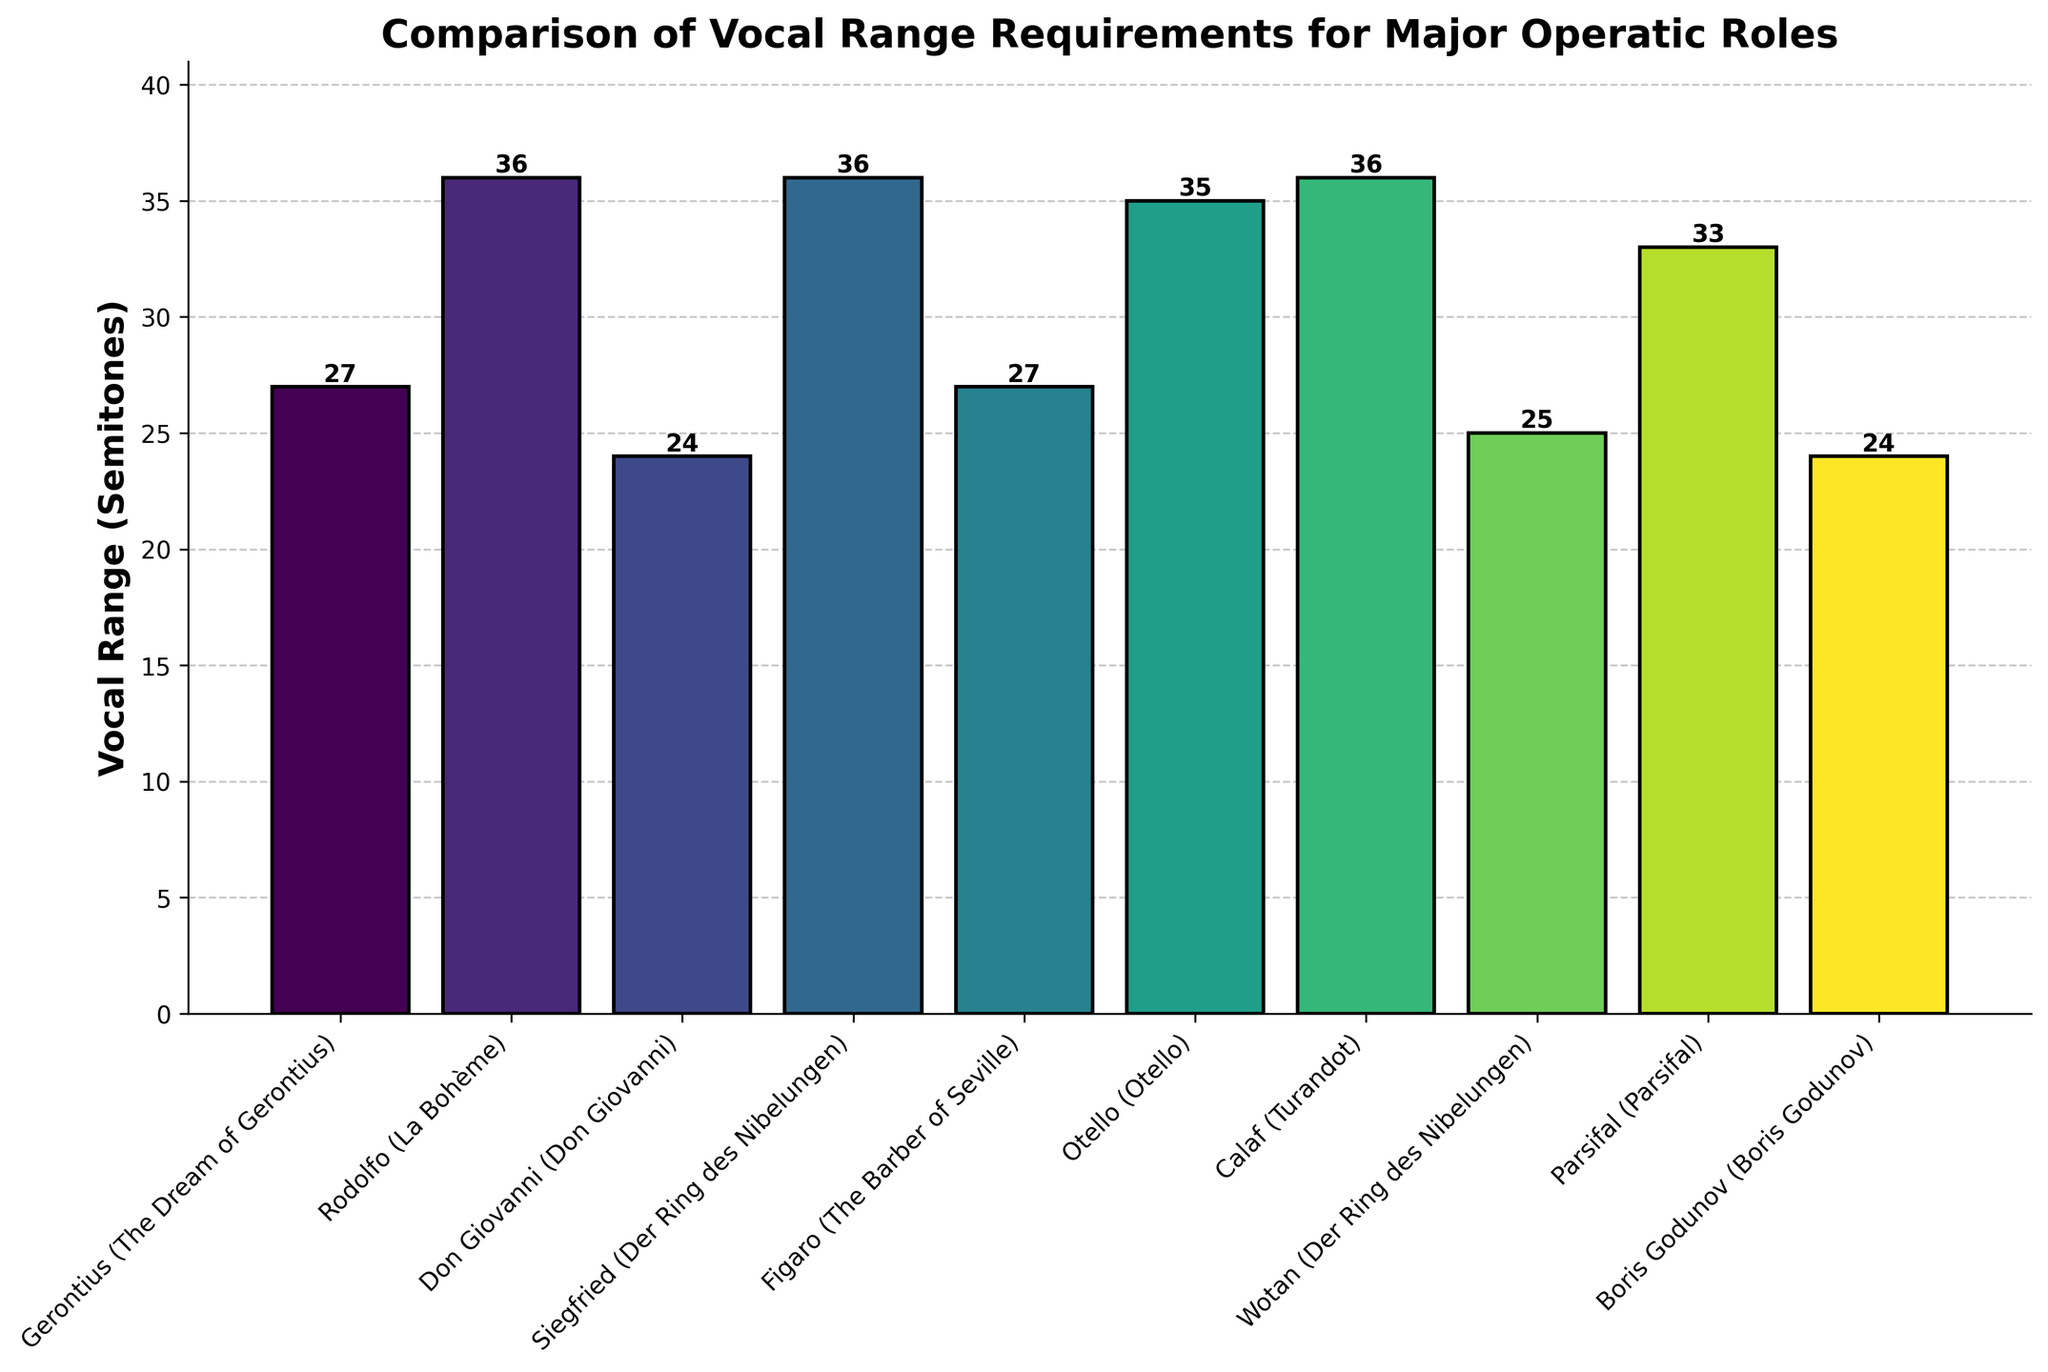What is the vocal range of Rodolfo in "La Bohème"? Look at the bar corresponding to Rodolfo in "La Bohème" and find the height, which represents the vocal range (semitones).
Answer: 36 Which operatic role has the widest vocal range, and what is that range? Identify the tallest bar in the chart and check the label and value attached to it.
Answer: Rodolfo and Siegfried with 36 semitones Which role has a narrower vocal range, Don Giovanni or Gerontius? Compare the heights of the bars for Don Giovanni and Gerontius. Don Giovanni's bar is shorter.
Answer: Don Giovanni How much broader is the vocal range of Parsifal compared to Gerontius? Calculate the difference in height between the bars for Parsifal and Gerontius. Parsifal has a higher value. Subtract Gerontius' range (27) from Parsifal's range (33).
Answer: 6 semitones Which role has the second widest vocal range? Find the second tallest bar in the chart. Otello has a 35 semitone range and is shorter compared to Rodolfo, Siegfried, and Calaf.
Answer: Otello How many roles have a vocal range greater than 30 semitones? Count the number of bars with heights greater than 30. Check each role and its range. Rodolfo, Siegfried, Otello, Calaf, and Parsifal have ranges greater than 30.
Answer: 5 roles Is the vocal range of Wotan in "Der Ring des Nibelungen" greater than or less than Boris Godunov? Compare the heights of the bars for Wotan and Boris Godunov. Both bars are the same height, representing equal ranges.
Answer: Equal What is the average vocal range of the roles listed in the plot? Add all the vocal ranges and divide by the number of roles: (27 + 36 + 24 + 36 + 27 + 35 + 36 + 25 + 33 + 24) / 10 = 30.3.
Answer: 30.3 semitones Which role has the lowest vocal range and what is the range in semitones? Identify the shortest bar in the chart and read the label and its height. Don Giovanni and Boris Godunov have the shortest bars.
Answer: Don Giovanni and Boris Godunov with 24 semitones 